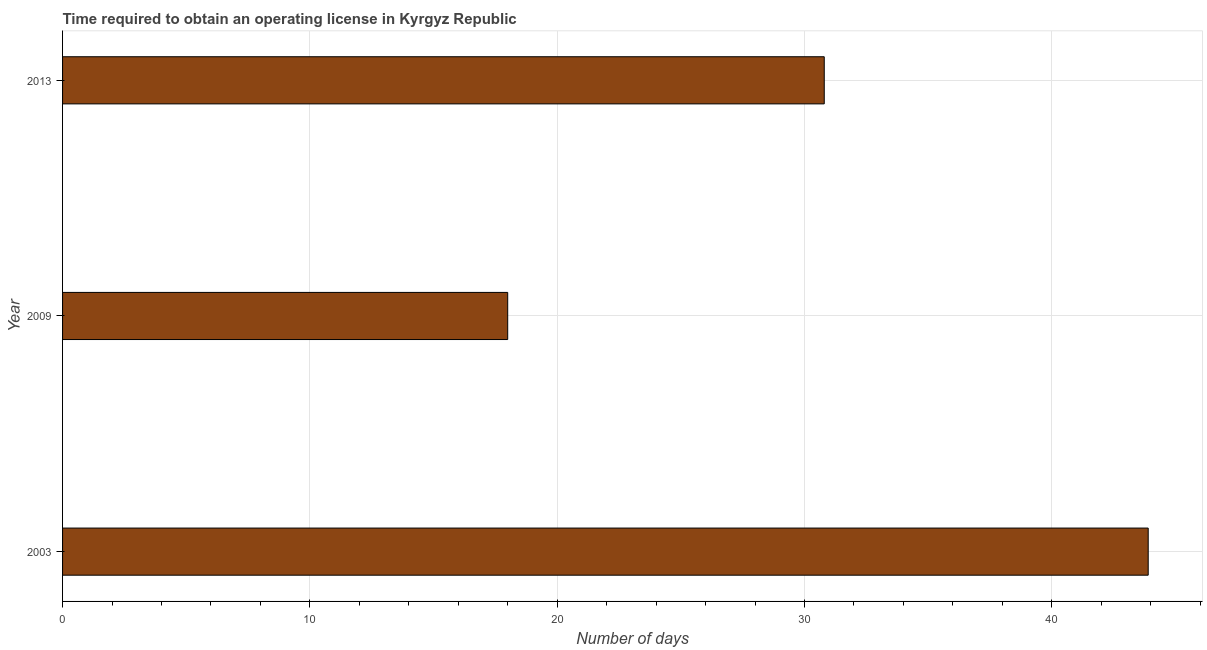Does the graph contain any zero values?
Your answer should be very brief. No. What is the title of the graph?
Offer a very short reply. Time required to obtain an operating license in Kyrgyz Republic. What is the label or title of the X-axis?
Offer a very short reply. Number of days. What is the label or title of the Y-axis?
Your answer should be compact. Year. Across all years, what is the maximum number of days to obtain operating license?
Offer a very short reply. 43.9. In which year was the number of days to obtain operating license minimum?
Provide a succinct answer. 2009. What is the sum of the number of days to obtain operating license?
Your response must be concise. 92.7. What is the difference between the number of days to obtain operating license in 2009 and 2013?
Provide a short and direct response. -12.8. What is the average number of days to obtain operating license per year?
Your answer should be very brief. 30.9. What is the median number of days to obtain operating license?
Provide a succinct answer. 30.8. In how many years, is the number of days to obtain operating license greater than 16 days?
Offer a terse response. 3. Do a majority of the years between 2009 and 2013 (inclusive) have number of days to obtain operating license greater than 8 days?
Your answer should be compact. Yes. What is the ratio of the number of days to obtain operating license in 2003 to that in 2009?
Ensure brevity in your answer.  2.44. Is the difference between the number of days to obtain operating license in 2003 and 2009 greater than the difference between any two years?
Provide a succinct answer. Yes. What is the difference between the highest and the second highest number of days to obtain operating license?
Make the answer very short. 13.1. What is the difference between the highest and the lowest number of days to obtain operating license?
Your answer should be very brief. 25.9. In how many years, is the number of days to obtain operating license greater than the average number of days to obtain operating license taken over all years?
Offer a terse response. 1. What is the difference between two consecutive major ticks on the X-axis?
Provide a short and direct response. 10. What is the Number of days of 2003?
Make the answer very short. 43.9. What is the Number of days in 2009?
Offer a very short reply. 18. What is the Number of days in 2013?
Offer a very short reply. 30.8. What is the difference between the Number of days in 2003 and 2009?
Your response must be concise. 25.9. What is the difference between the Number of days in 2009 and 2013?
Give a very brief answer. -12.8. What is the ratio of the Number of days in 2003 to that in 2009?
Your answer should be compact. 2.44. What is the ratio of the Number of days in 2003 to that in 2013?
Your answer should be very brief. 1.43. What is the ratio of the Number of days in 2009 to that in 2013?
Make the answer very short. 0.58. 